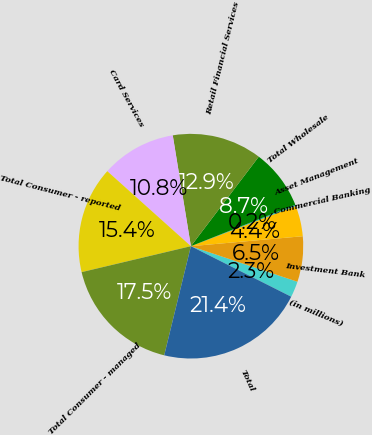<chart> <loc_0><loc_0><loc_500><loc_500><pie_chart><fcel>(in millions)<fcel>Investment Bank<fcel>Commercial Banking<fcel>Asset Management<fcel>Total Wholesale<fcel>Retail Financial Services<fcel>Card Services<fcel>Total Consumer - reported<fcel>Total Consumer - managed<fcel>Total<nl><fcel>2.3%<fcel>6.54%<fcel>4.42%<fcel>0.18%<fcel>8.66%<fcel>12.91%<fcel>10.78%<fcel>15.35%<fcel>17.47%<fcel>21.39%<nl></chart> 